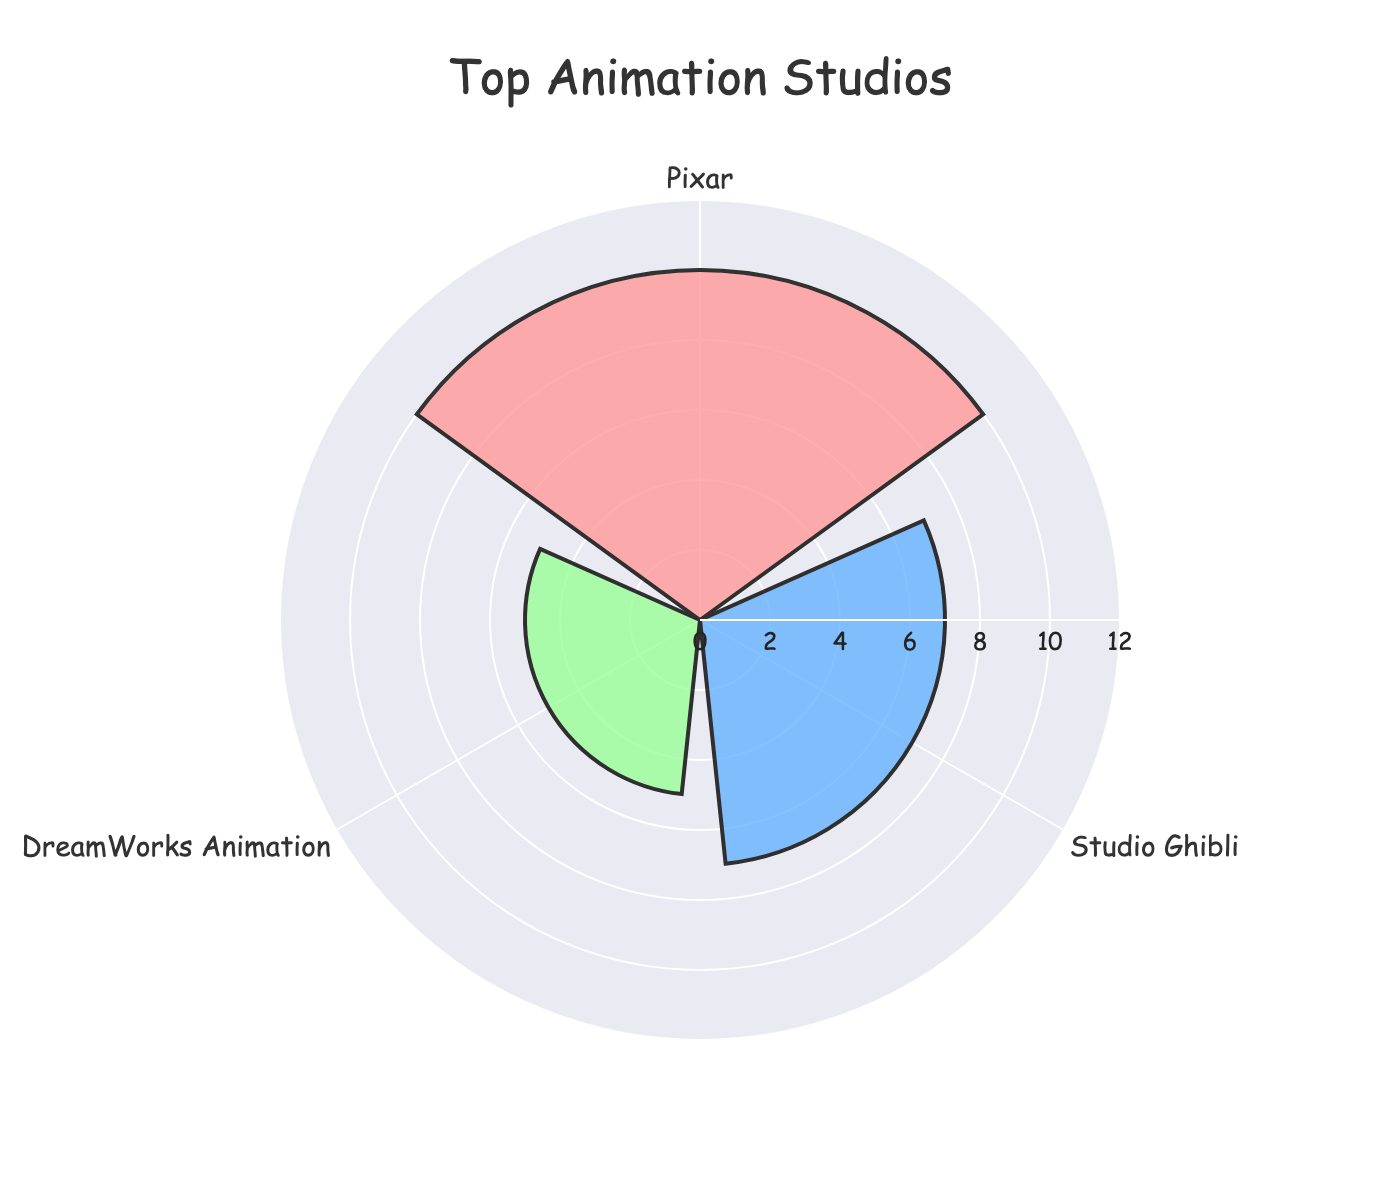What's the title of the figure? The title is usually located at the top of the chart. In this case, the title reads "Top Animation Studios".
Answer: Top Animation Studios How many studios are represented in the chart? Look at the different theta (angular) positions, which represent different studios. Count the unique studios listed.
Answer: 3 Which animation studio has produced the most top-ranked films? By examining the length of the radial bars, the longest bar represents the studio with the most films. Pixar has the longest bar.
Answer: Pixar What are the colors used to represent the different studios? Check the bars' colors for each studio. The studios are represented by pink, blue, and green.
Answer: Pink, blue, green What's the combined total of top-ranked films produced by the studios shown in the chart? Add the values for the top-ranked films of each studio (10 + 7 + 5).
Answer: 22 Which studio has produced less top-ranked films than Studio Ghibli but more than Illumination Entertainment? Comparison involves looking at the mid-length bar. DreamWorks Animation falls between Studio Ghibli and Illumination Entertainment in terms of the number of films.
Answer: DreamWorks Animation How many more top-ranked films has Pixar produced compared to DreamWorks Animation? Subtract the value for DreamWorks Animation (5) from Pixar (10).
Answer: 5 What is the average number of top-ranked films produced by the three studios? Add the numbers (10 + 7 + 5) to get 22, then divide by 3.
Answer: 7.33 Which of the studios in the chart produced the fewest top-ranked films? The shortest bar represents the studio with the fewest films. DreamWorks Animation has the shortest bar.
Answer: DreamWorks Animation What is the visual characteristic distinguishing different studios in the chart? Different studios are distinguished by the colors of their bars in the rose chart.
Answer: Colors 